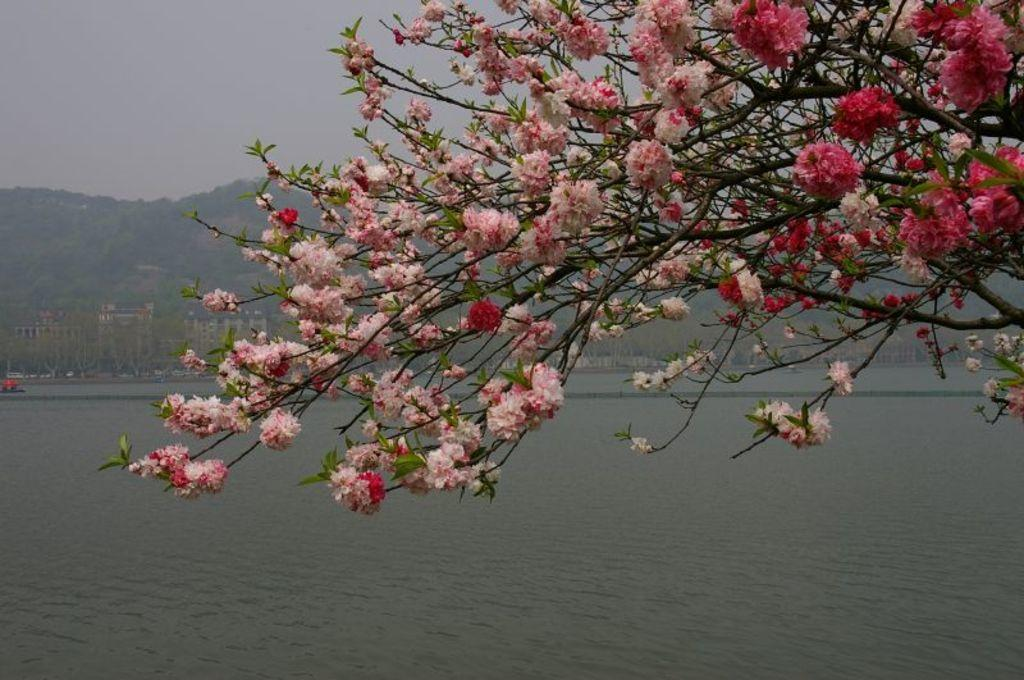What can be seen in the middle of the image? There are trees, flowers, and stems in the middle of the image. What is located at the bottom of the image? There is water at the bottom of the image. What is visible in the background of the image? There are hills and the sky in the background of the image. Is there a trampoline visible in the image? There is no trampoline present in the image. 